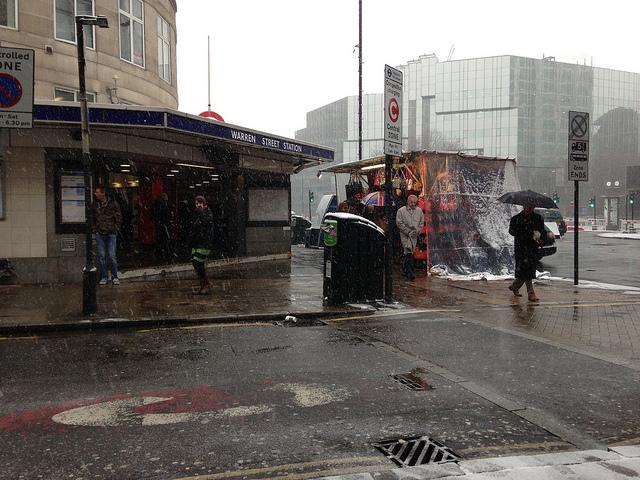What is on the street?
Answer briefly. Rain. How many umbrellas are open?
Give a very brief answer. 1. What sign is next to the man?
Be succinct. No parking. Is it raining?
Give a very brief answer. Yes. 